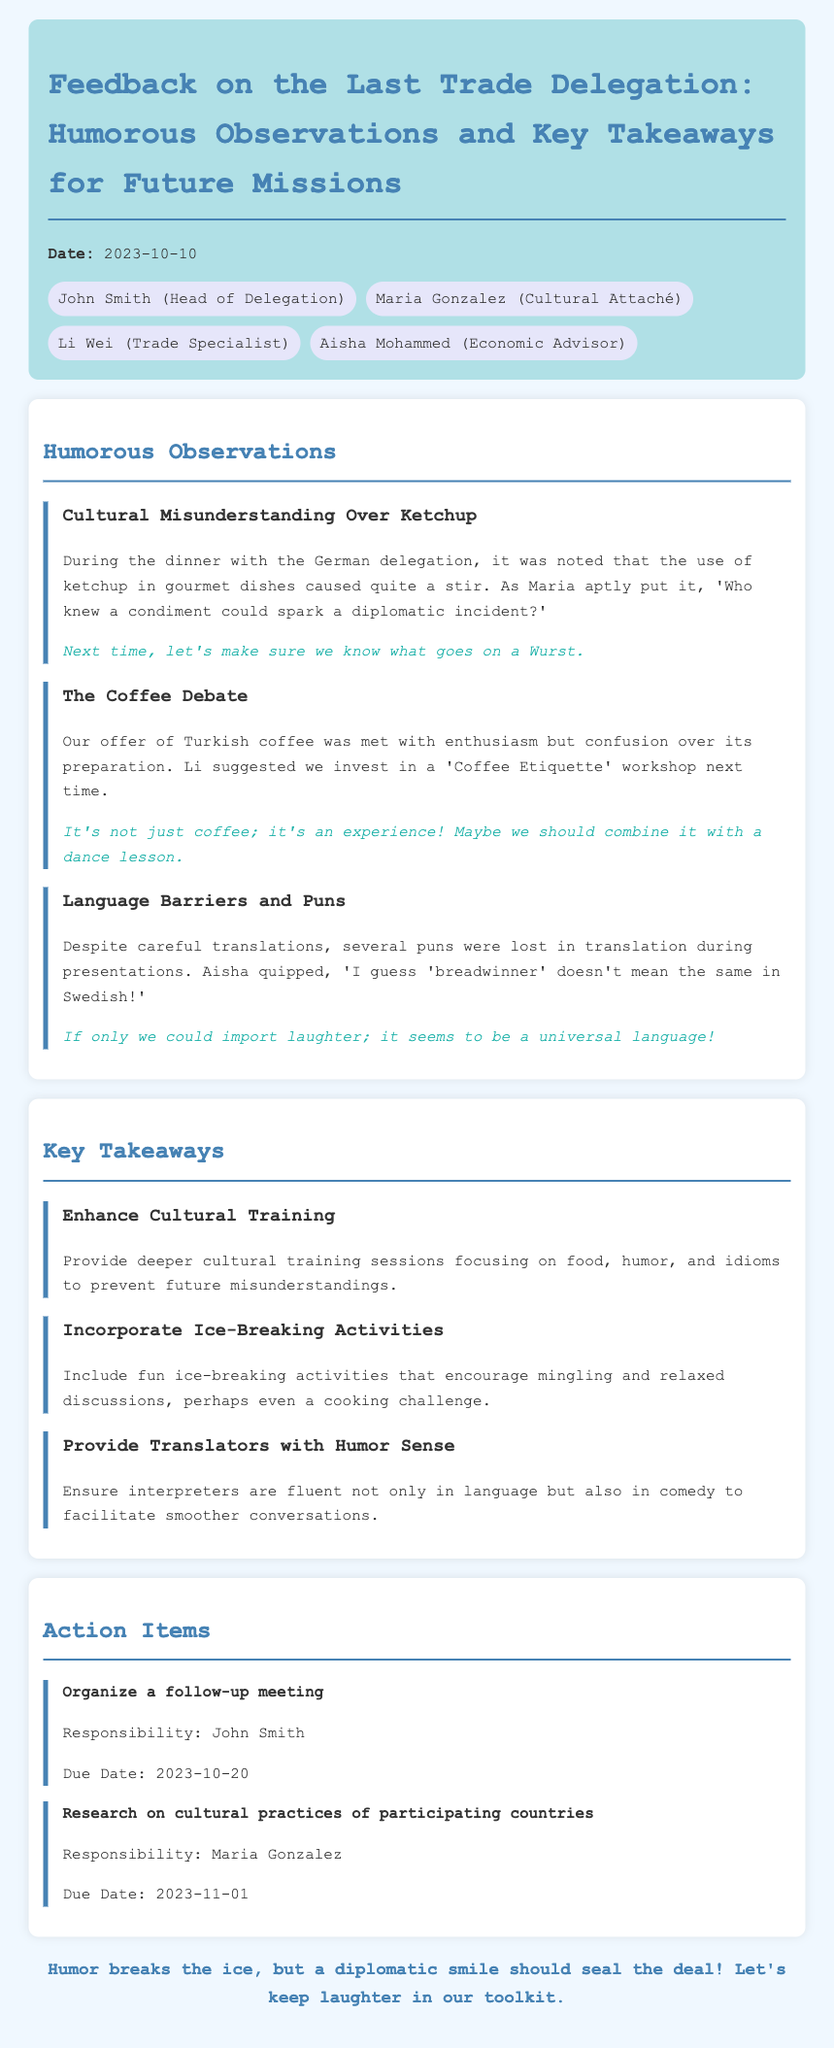What date was the meeting held? The date of the meeting is indicated at the beginning of the document.
Answer: 2023-10-10 Who is the Head of Delegation? The document lists participants and their roles, specifically naming the Head of Delegation.
Answer: John Smith What was one of the humorous observations related to food? The document mentions a specific cultural misunderstanding regarding food during the delegation.
Answer: Cultural Misunderstanding Over Ketchup What key takeaway relates to cultural training? The document provides key takeaways from the meeting, including one focused on cultural training.
Answer: Enhance Cultural Training What is one action item mentioned in the document? The document outlines specific action items with corresponding responsibilities and due dates.
Answer: Organize a follow-up meeting How many participants are listed in the document? The number of participants can be counted from the participants section in the document.
Answer: Four What type of workshops does Li suggest? The document highlights a suggestion made by Li regarding a type of workshop.
Answer: Coffee Etiquette What humorous remark did Aisha make? The document captures a specific humorous observation made by Aisha during the meeting.
Answer: I guess 'breadwinner' doesn't mean the same in Swedish! 